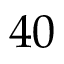<formula> <loc_0><loc_0><loc_500><loc_500>4 0</formula> 